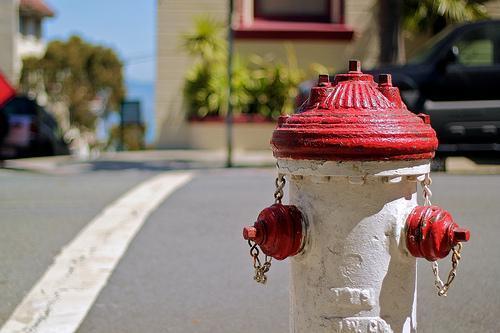How many cars are visible in the background?
Give a very brief answer. 2. How many whit lines cross the street?
Give a very brief answer. 1. 